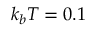Convert formula to latex. <formula><loc_0><loc_0><loc_500><loc_500>k _ { b } T = 0 . 1</formula> 